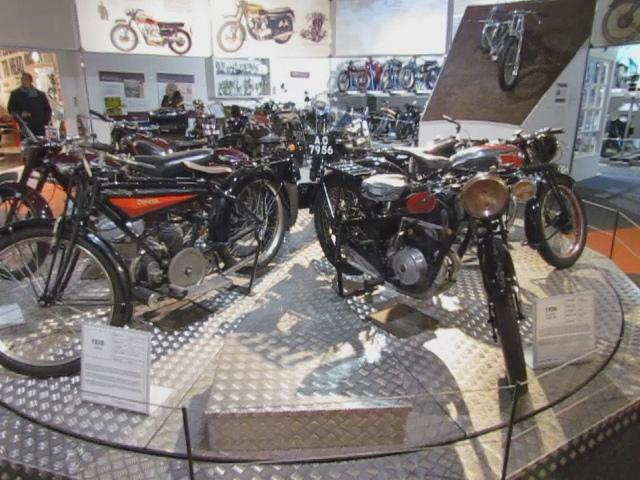What sort of shop is this? motorcycle 